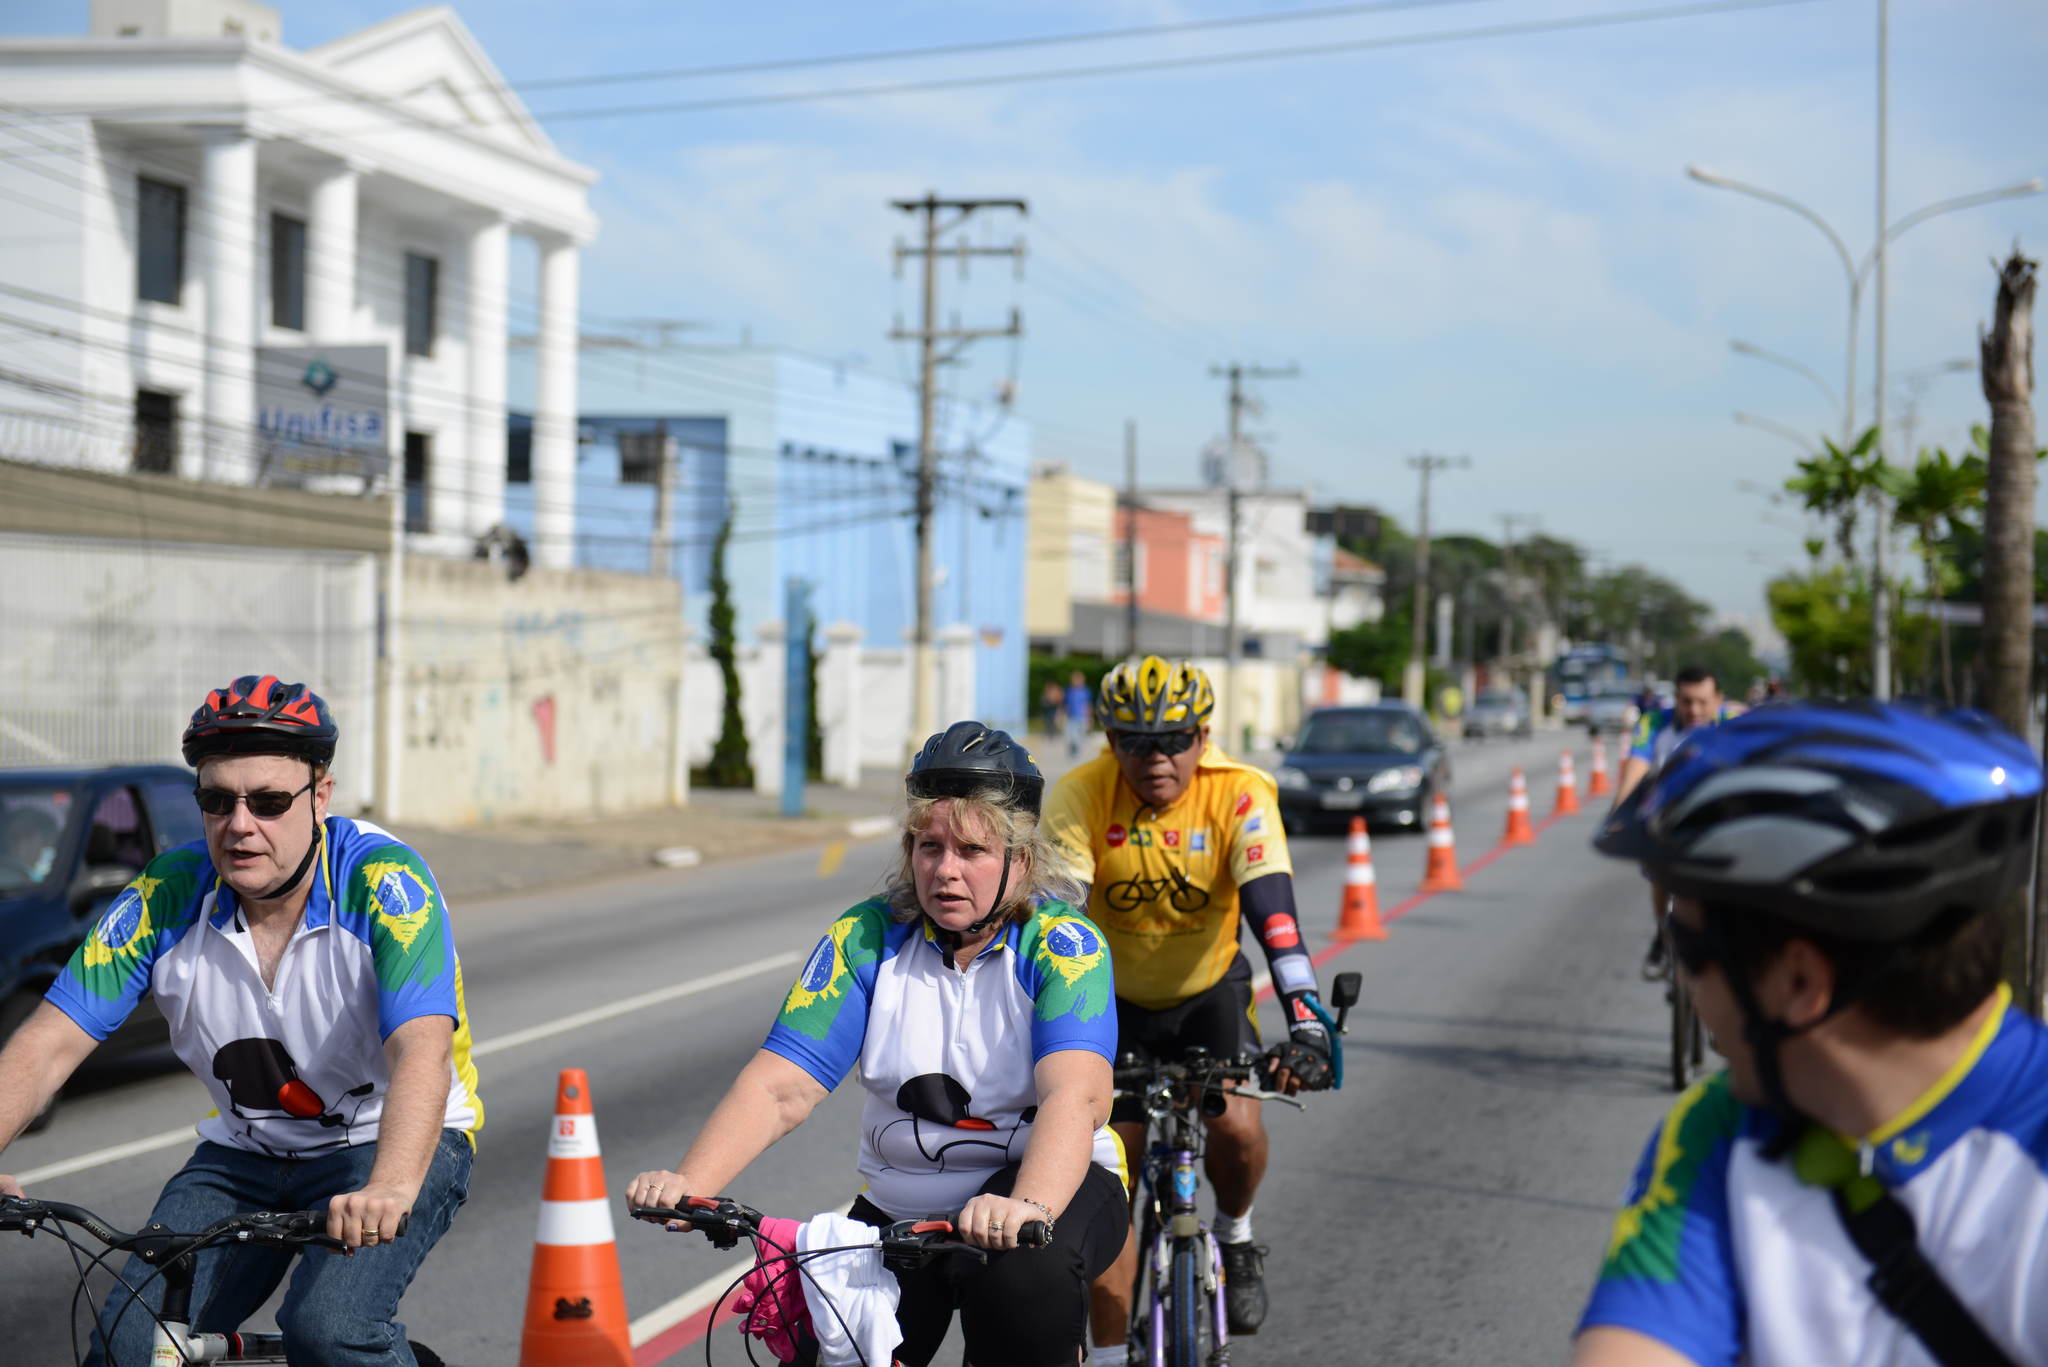Describe this image in one or two sentences. In this image there are group of people riding their bicycles in the street ,and in back ground there are buildings, poles, trees, cars, and sky covered with clouds. 